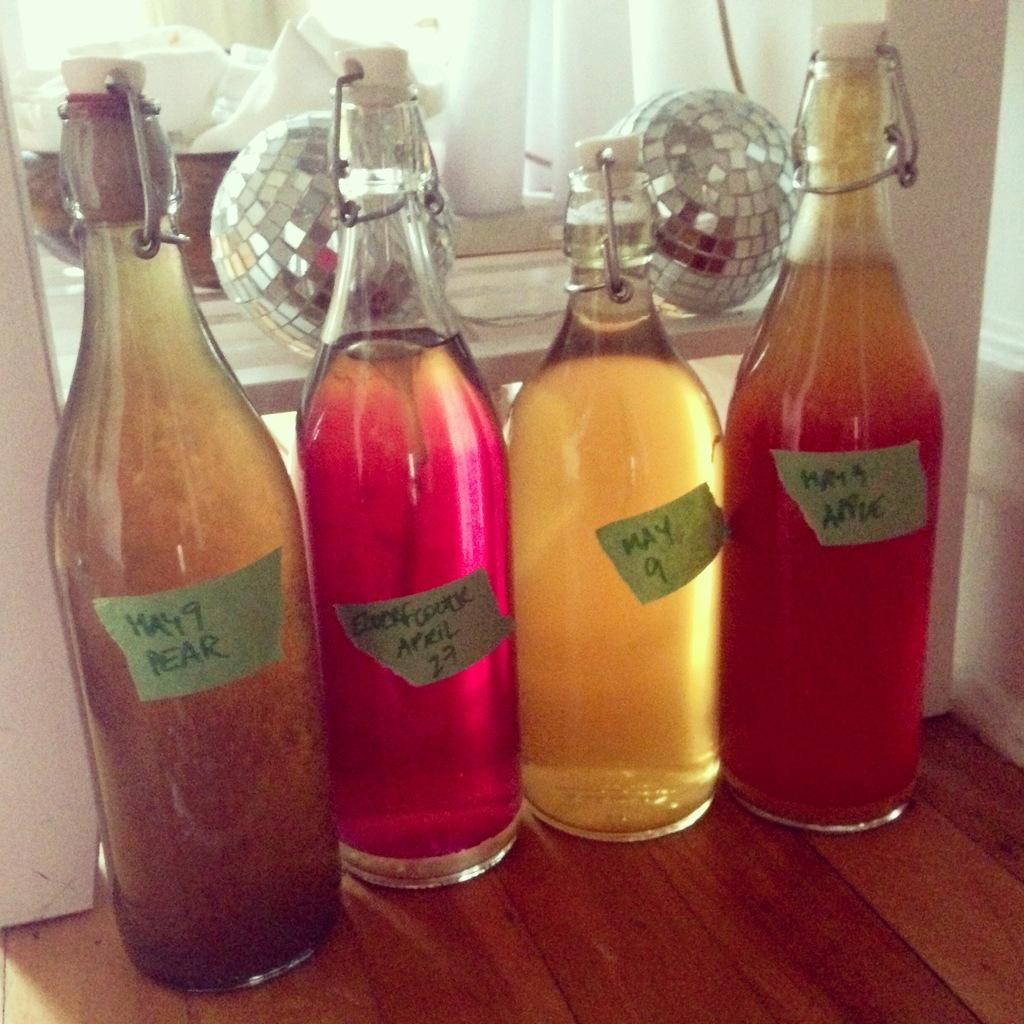<image>
Share a concise interpretation of the image provided. Some bottles of homemade drinks have tape labels on them that say May 9. 